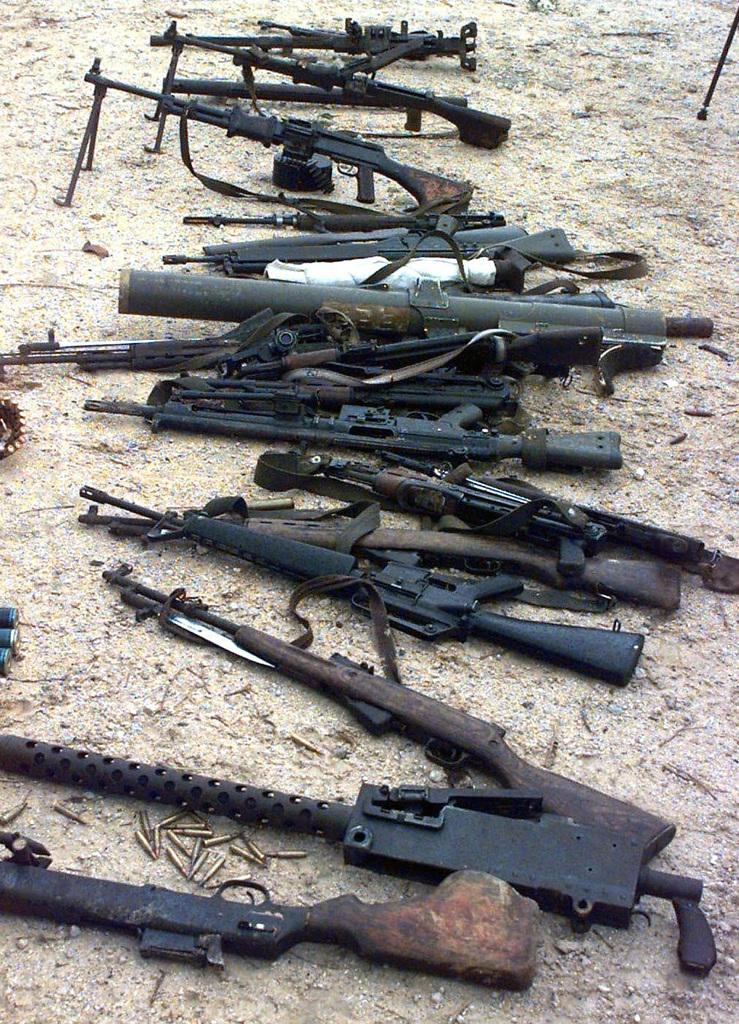What types of weapons are in the image? There are different types of rifles in the image. Where are the rifles located in the image? The rifles are in the center of the image. What type of butter is being used to grease the rifles in the image? There is no butter present in the image, and the rifles are not being greased. 